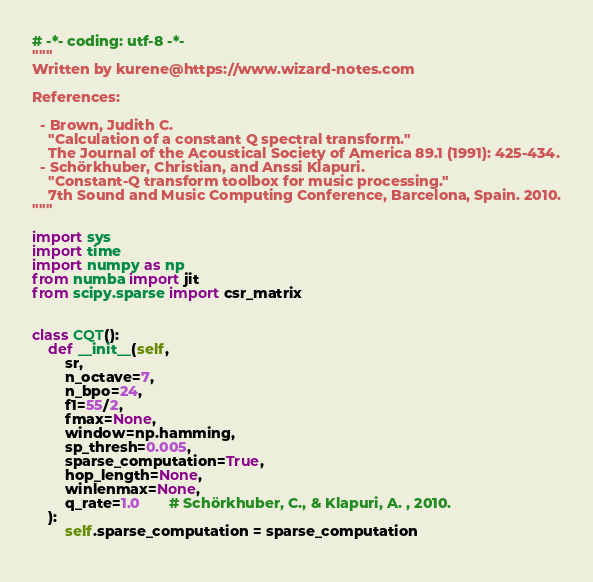Convert code to text. <code><loc_0><loc_0><loc_500><loc_500><_Python_># -*- coding: utf-8 -*-
"""
Written by kurene@https://www.wizard-notes.com

References:

  - Brown, Judith C. 
    "Calculation of a constant Q spectral transform." 
    The Journal of the Acoustical Society of America 89.1 (1991): 425-434.
  - Schörkhuber, Christian, and Anssi Klapuri. 
    "Constant-Q transform toolbox for music processing."
    7th Sound and Music Computing Conference, Barcelona, Spain. 2010.
"""

import sys
import time
import numpy as np
from numba import jit
from scipy.sparse import csr_matrix

    
class CQT():
    def __init__(self, 
        sr,
        n_octave=7,
        n_bpo=24,
        f1=55/2,
        fmax=None,
        window=np.hamming,
        sp_thresh=0.005,
        sparse_computation=True,
        hop_length=None,
        winlenmax=None,
        q_rate=1.0       # Schörkhuber, C., & Klapuri, A. , 2010.
    ):
        self.sparse_computation = sparse_computation
        </code> 